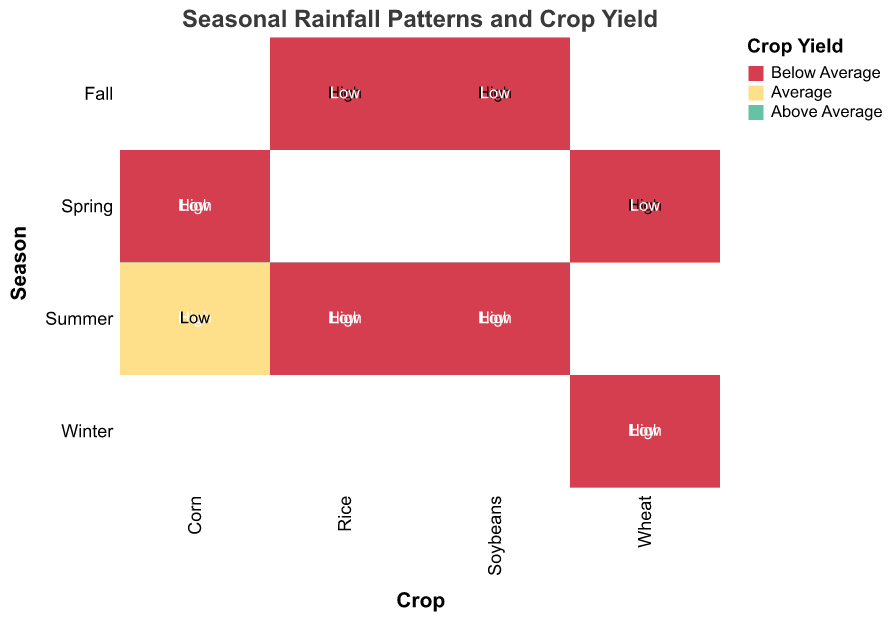What is the yield for Corn in Summer with High rainfall? Look at the section of the mosaic plot labeled "Corn" and cross-reference with "Summer" and "High" rainfall. The yield is colored green, which corresponds to "Above Average" in the legend.
Answer: Above Average What color represents the "Below Average" yield? Refer to the legend on the plot, where each yield category is associated with a specific color. "Below Average" is represented by red.
Answer: Red Which crop shows an "Average" yield in Spring with High rainfall? Identify the "Spring" season in the mosaic plot and then look at the crop sections with "High" rainfall. The "Average" yield in Spring with High rainfall is represented by the color yellow in Wheat.
Answer: Wheat In which season does Rice have an Above Average yield? Locate the "Rice" section in the mosaic plot, then find the areas that are colored green, which indicates "Above Average" yield. These areas are in "Summer".
Answer: Summer How many crop and season combinations result in a "Below Average" yield with Low rainfall? Identify the sections with "Low" rainfall and cross-check the number of times the yield is indicated by red (Below Average yield). This happens for Corn (Spring and Summer), Wheat (Winter and Spring), Soybeans (Summer and Fall), and Rice (Summer and Fall).
Answer: Eight combinations Which crop has the most variable yield across different seasons? Compare the color variety within each crop's section. Corn shows yield variability with all types (Above Average, Average, Below Average) present across different seasons.
Answer: Corn How does the yield for Soybeans compare between Summer and Fall with High rainfall? Look at the plot sections for "Soybeans," focusing on "Summer" and "Fall" with High rainfall. In "Summer," the yield is "Above Average" (green), while in "Fall," the yield is "Average" (yellow).
Answer: Summer yield is Above Average, Fall yield is Average 